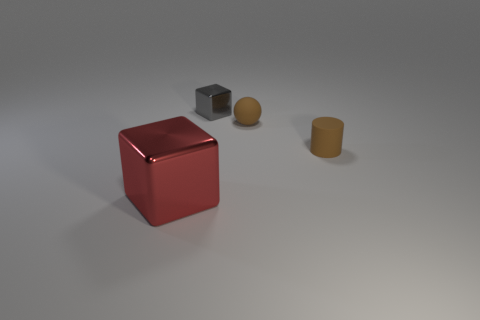Subtract all red blocks. How many blocks are left? 1 Subtract all cylinders. How many objects are left? 3 Add 3 gray shiny cubes. How many objects exist? 7 Subtract all green balls. Subtract all blue cylinders. How many balls are left? 1 Subtract all tiny cylinders. Subtract all big rubber things. How many objects are left? 3 Add 1 tiny brown balls. How many tiny brown balls are left? 2 Add 3 cyan matte things. How many cyan matte things exist? 3 Subtract 0 yellow blocks. How many objects are left? 4 